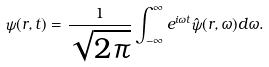<formula> <loc_0><loc_0><loc_500><loc_500>\psi ( r , t ) = \frac { 1 } { \sqrt { 2 \pi } } \int ^ { \infty } _ { - \infty } e ^ { i \omega t } \hat { \psi } ( r , \omega ) d \omega .</formula> 